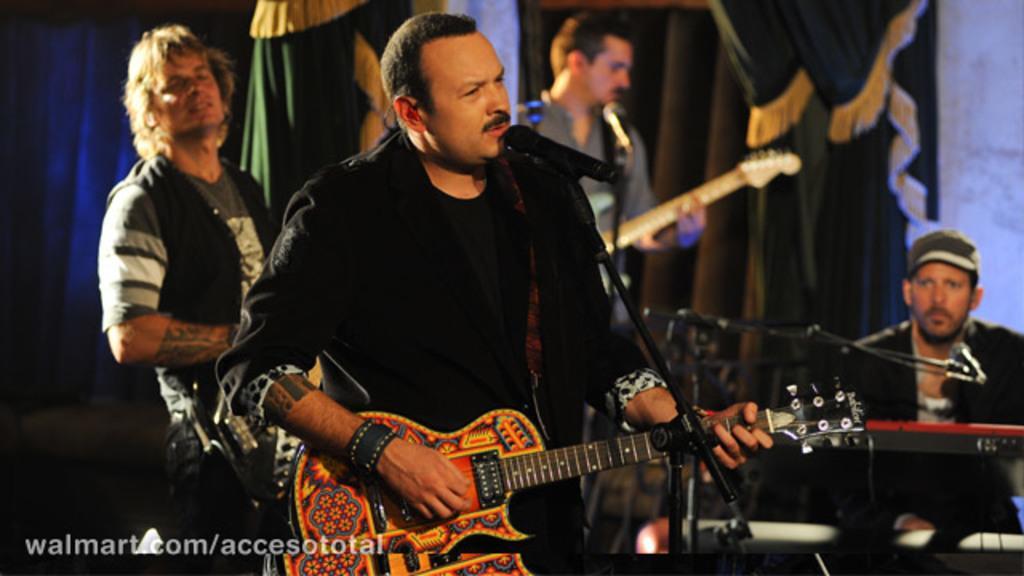Please provide a concise description of this image. This image is clicked in a concert. There are many people in this image. In the front the man wearing black suit is singing and playing guitar. To the right, the man is playing piano. In the background, there are curtains and wall. 